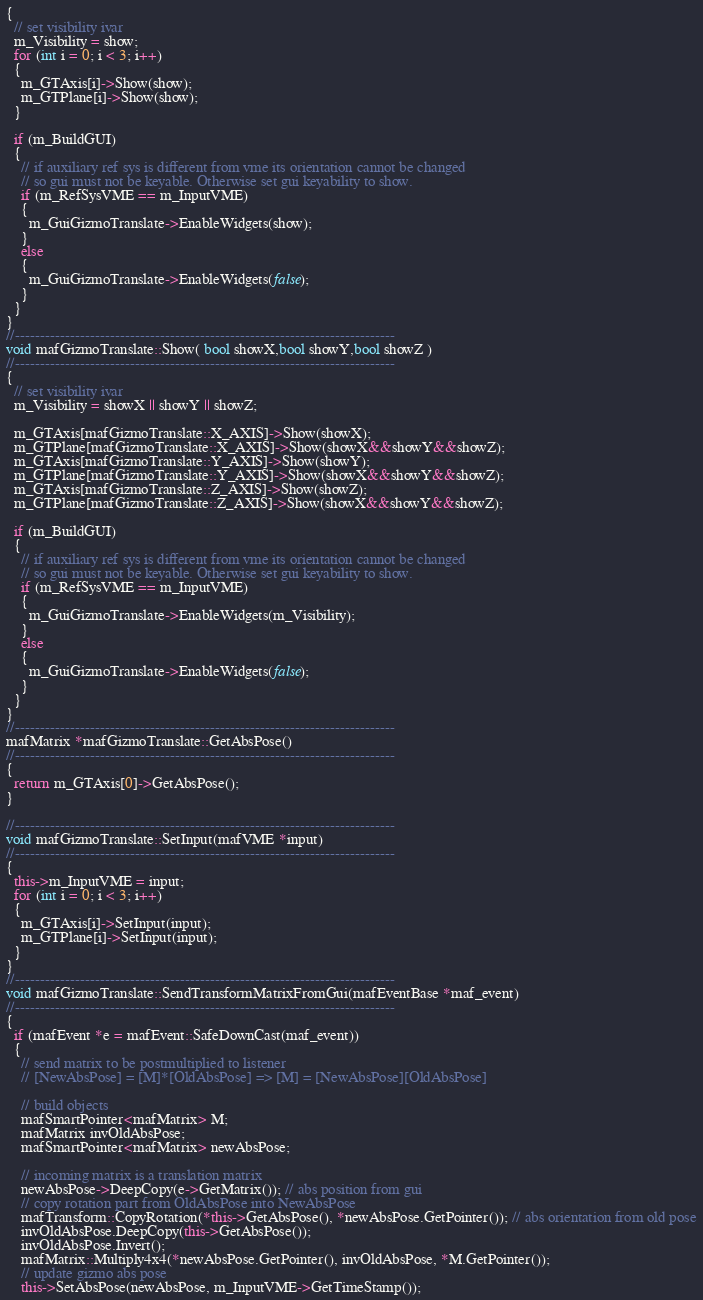Convert code to text. <code><loc_0><loc_0><loc_500><loc_500><_C++_>{
  // set visibility ivar
  m_Visibility = show;
  for (int i = 0; i < 3; i++)
  {
    m_GTAxis[i]->Show(show);
    m_GTPlane[i]->Show(show);
  }

  if (m_BuildGUI)
  {
    // if auxiliary ref sys is different from vme its orientation cannot be changed
    // so gui must not be keyable. Otherwise set gui keyability to show.
    if (m_RefSysVME == m_InputVME)
    {
      m_GuiGizmoTranslate->EnableWidgets(show);
    }
    else
    {
      m_GuiGizmoTranslate->EnableWidgets(false);
    }
  }
}
//----------------------------------------------------------------------------
void mafGizmoTranslate::Show( bool showX,bool showY,bool showZ )
//----------------------------------------------------------------------------
{
  // set visibility ivar
  m_Visibility = showX || showY || showZ;

  m_GTAxis[mafGizmoTranslate::X_AXIS]->Show(showX);
  m_GTPlane[mafGizmoTranslate::X_AXIS]->Show(showX&&showY&&showZ);
  m_GTAxis[mafGizmoTranslate::Y_AXIS]->Show(showY);
  m_GTPlane[mafGizmoTranslate::Y_AXIS]->Show(showX&&showY&&showZ);
  m_GTAxis[mafGizmoTranslate::Z_AXIS]->Show(showZ);
  m_GTPlane[mafGizmoTranslate::Z_AXIS]->Show(showX&&showY&&showZ);

  if (m_BuildGUI)
  {
    // if auxiliary ref sys is different from vme its orientation cannot be changed
    // so gui must not be keyable. Otherwise set gui keyability to show.
    if (m_RefSysVME == m_InputVME)
    {
      m_GuiGizmoTranslate->EnableWidgets(m_Visibility);
    }
    else
    {
      m_GuiGizmoTranslate->EnableWidgets(false);
    }
  }
}
//----------------------------------------------------------------------------
mafMatrix *mafGizmoTranslate::GetAbsPose()
//----------------------------------------------------------------------------
{
  return m_GTAxis[0]->GetAbsPose();
}

//----------------------------------------------------------------------------  
void mafGizmoTranslate::SetInput(mafVME *input)
//----------------------------------------------------------------------------
{
  this->m_InputVME = input;
  for (int i = 0; i < 3; i++)
  {
    m_GTAxis[i]->SetInput(input);
    m_GTPlane[i]->SetInput(input);
  }
}
//----------------------------------------------------------------------------
void mafGizmoTranslate::SendTransformMatrixFromGui(mafEventBase *maf_event)
//----------------------------------------------------------------------------
{
  if (mafEvent *e = mafEvent::SafeDownCast(maf_event))
  {
    // send matrix to be postmultiplied to listener
    // [NewAbsPose] = [M]*[OldAbsPose] => [M] = [NewAbsPose][OldAbsPose]

    // build objects
    mafSmartPointer<mafMatrix> M;
    mafMatrix invOldAbsPose;
    mafSmartPointer<mafMatrix> newAbsPose;

    // incoming matrix is a translation matrix
    newAbsPose->DeepCopy(e->GetMatrix()); // abs position from gui
    // copy rotation part from OldAbsPose into NewAbsPose
    mafTransform::CopyRotation(*this->GetAbsPose(), *newAbsPose.GetPointer()); // abs orientation from old pose
    invOldAbsPose.DeepCopy(this->GetAbsPose());
    invOldAbsPose.Invert();
    mafMatrix::Multiply4x4(*newAbsPose.GetPointer(), invOldAbsPose, *M.GetPointer());
    // update gizmo abs pose
    this->SetAbsPose(newAbsPose, m_InputVME->GetTimeStamp());</code> 